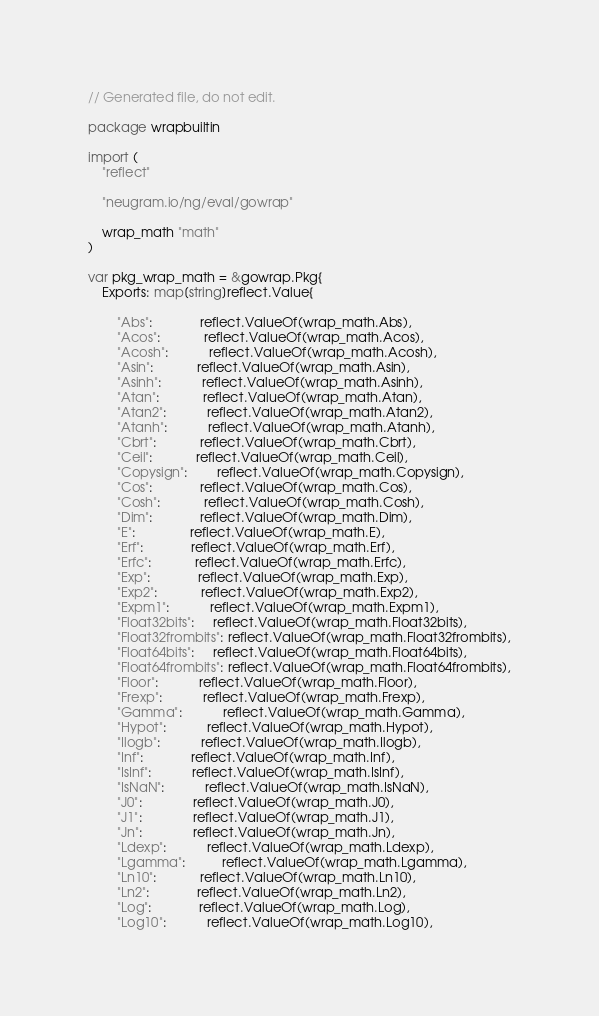Convert code to text. <code><loc_0><loc_0><loc_500><loc_500><_Go_>// Generated file, do not edit.

package wrapbuiltin

import (
	"reflect"

	"neugram.io/ng/eval/gowrap"

	wrap_math "math"
)

var pkg_wrap_math = &gowrap.Pkg{
	Exports: map[string]reflect.Value{

		"Abs":             reflect.ValueOf(wrap_math.Abs),
		"Acos":            reflect.ValueOf(wrap_math.Acos),
		"Acosh":           reflect.ValueOf(wrap_math.Acosh),
		"Asin":            reflect.ValueOf(wrap_math.Asin),
		"Asinh":           reflect.ValueOf(wrap_math.Asinh),
		"Atan":            reflect.ValueOf(wrap_math.Atan),
		"Atan2":           reflect.ValueOf(wrap_math.Atan2),
		"Atanh":           reflect.ValueOf(wrap_math.Atanh),
		"Cbrt":            reflect.ValueOf(wrap_math.Cbrt),
		"Ceil":            reflect.ValueOf(wrap_math.Ceil),
		"Copysign":        reflect.ValueOf(wrap_math.Copysign),
		"Cos":             reflect.ValueOf(wrap_math.Cos),
		"Cosh":            reflect.ValueOf(wrap_math.Cosh),
		"Dim":             reflect.ValueOf(wrap_math.Dim),
		"E":               reflect.ValueOf(wrap_math.E),
		"Erf":             reflect.ValueOf(wrap_math.Erf),
		"Erfc":            reflect.ValueOf(wrap_math.Erfc),
		"Exp":             reflect.ValueOf(wrap_math.Exp),
		"Exp2":            reflect.ValueOf(wrap_math.Exp2),
		"Expm1":           reflect.ValueOf(wrap_math.Expm1),
		"Float32bits":     reflect.ValueOf(wrap_math.Float32bits),
		"Float32frombits": reflect.ValueOf(wrap_math.Float32frombits),
		"Float64bits":     reflect.ValueOf(wrap_math.Float64bits),
		"Float64frombits": reflect.ValueOf(wrap_math.Float64frombits),
		"Floor":           reflect.ValueOf(wrap_math.Floor),
		"Frexp":           reflect.ValueOf(wrap_math.Frexp),
		"Gamma":           reflect.ValueOf(wrap_math.Gamma),
		"Hypot":           reflect.ValueOf(wrap_math.Hypot),
		"Ilogb":           reflect.ValueOf(wrap_math.Ilogb),
		"Inf":             reflect.ValueOf(wrap_math.Inf),
		"IsInf":           reflect.ValueOf(wrap_math.IsInf),
		"IsNaN":           reflect.ValueOf(wrap_math.IsNaN),
		"J0":              reflect.ValueOf(wrap_math.J0),
		"J1":              reflect.ValueOf(wrap_math.J1),
		"Jn":              reflect.ValueOf(wrap_math.Jn),
		"Ldexp":           reflect.ValueOf(wrap_math.Ldexp),
		"Lgamma":          reflect.ValueOf(wrap_math.Lgamma),
		"Ln10":            reflect.ValueOf(wrap_math.Ln10),
		"Ln2":             reflect.ValueOf(wrap_math.Ln2),
		"Log":             reflect.ValueOf(wrap_math.Log),
		"Log10":           reflect.ValueOf(wrap_math.Log10),</code> 